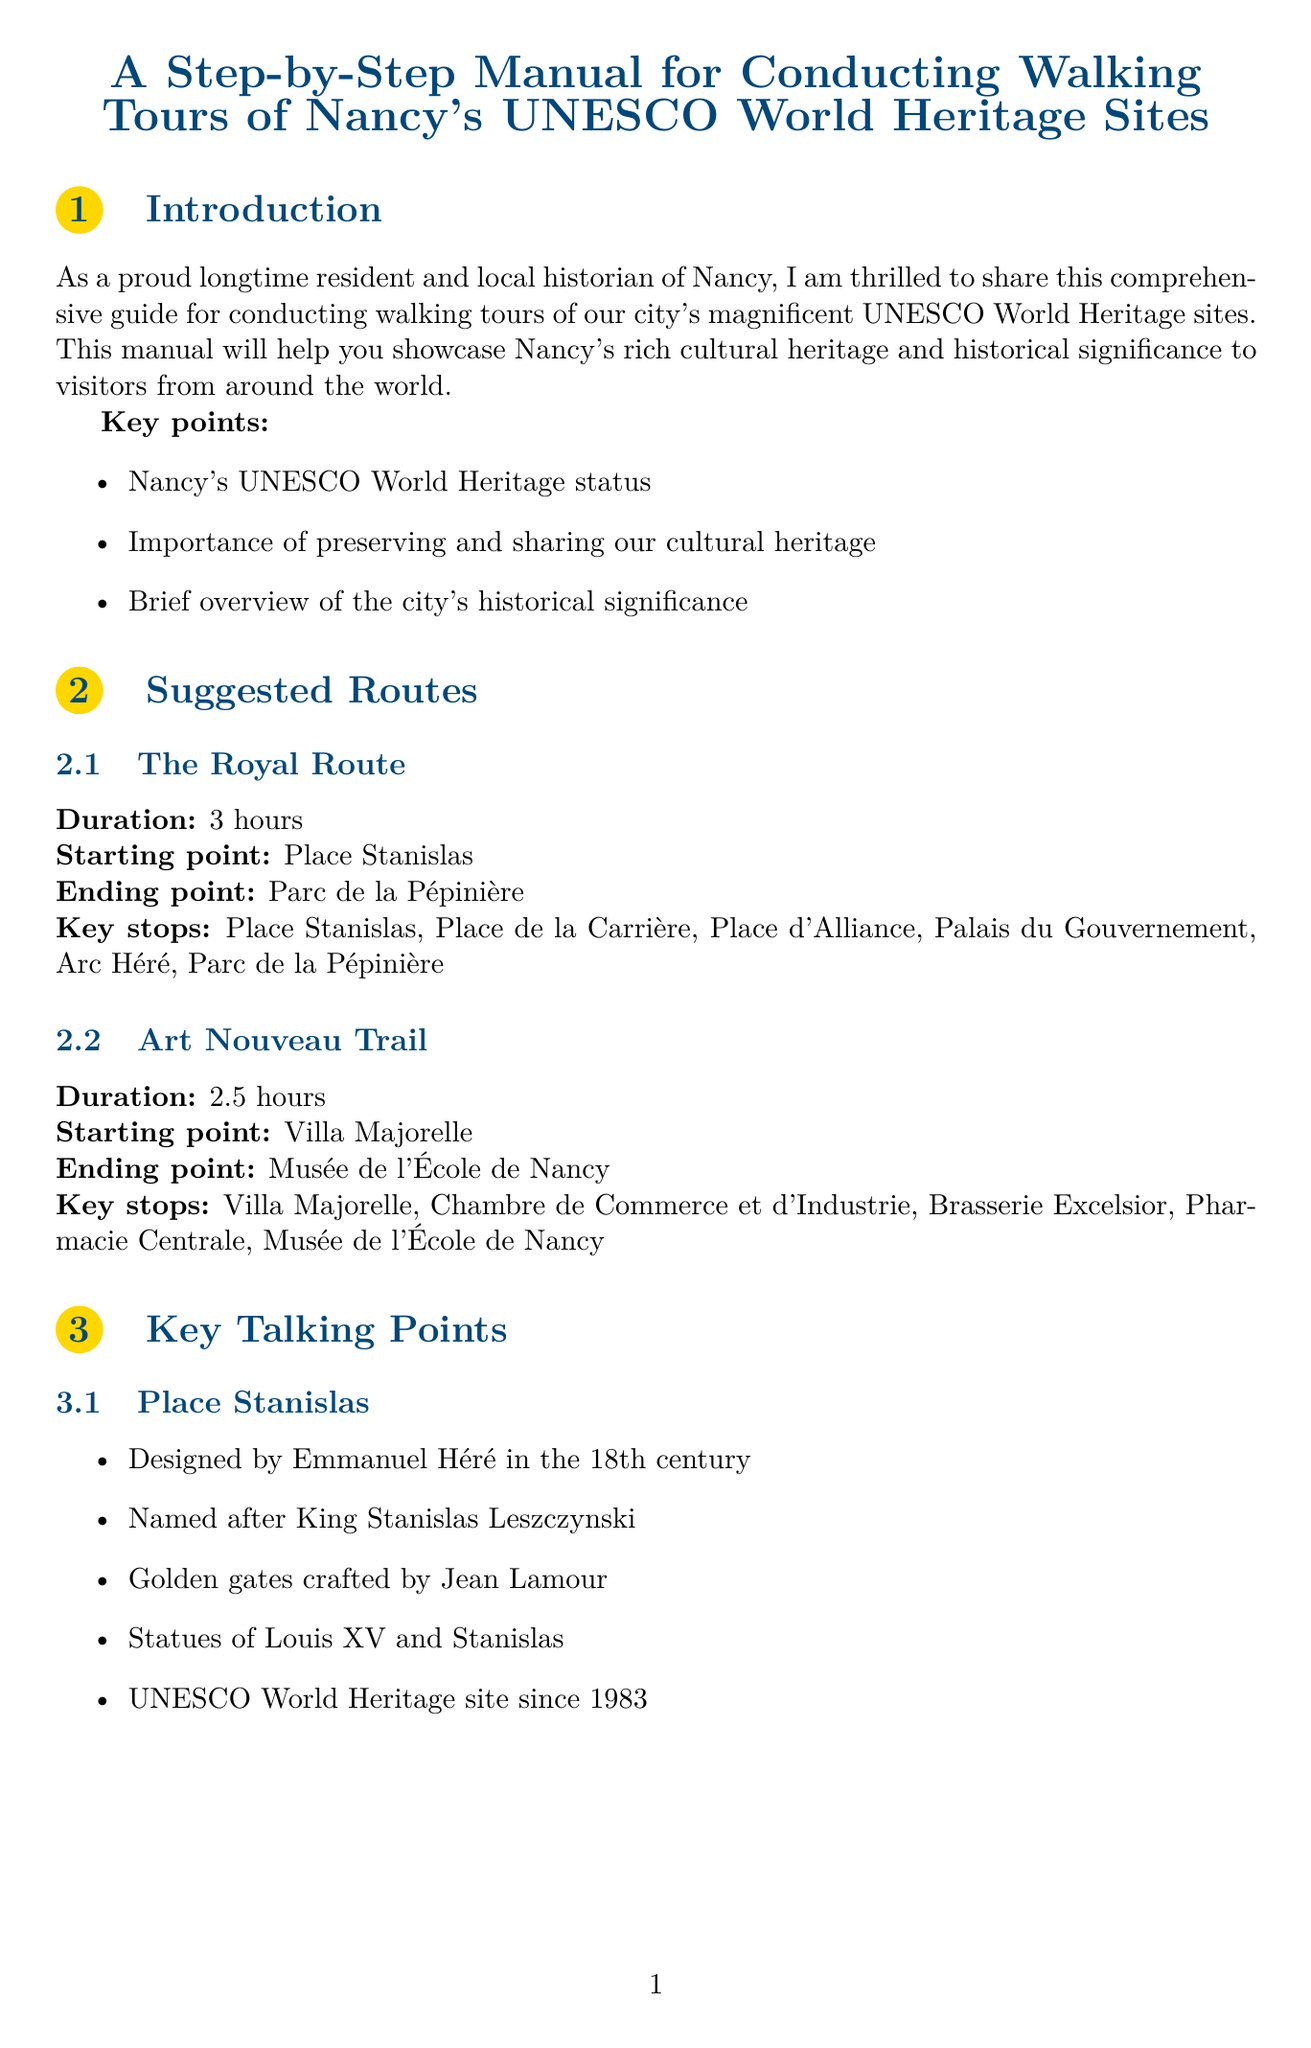What is the title of the manual? The title is explicitly stated at the beginning of the document.
Answer: A Step-by-Step Manual for Conducting Walking Tours of Nancy's UNESCO World Heritage Sites How long is the Royal Route? The duration of the Royal Route is specified in the suggested routes section.
Answer: 3 hours Who designed Place Stanislas? The document identifies the designer of Place Stanislas in the key talking points.
Answer: Emmanuel Héré Which site is dedicated to the Art Nouveau movement? The document specifies in the key talking points which site focuses on the Art Nouveau movement.
Answer: Musée de l'École de Nancy What is one of the key periods mentioned in the historical context? The document outlines historical periods, and one example is provided.
Answer: Medieval Nancy What is a tip for tour guides regarding visitor engagement? The tour guide tips section includes various tips related to visitor participation.
Answer: Encourage questions and engagement from tour participants How many key stops are on the Art Nouveau Trail? The document lists the key stops for the Art Nouveau Trail, which can be counted.
Answer: 5 Where can you find the Nancy Tourist Office? The additional resources section specifies the location of the Nancy Tourist Office.
Answer: Place Stanislas Which route is wheelchair accessible? The document includes information on wheelchair accessible routes in the accessibility information section.
Answer: Place Stanislas to Place de la Carrière 